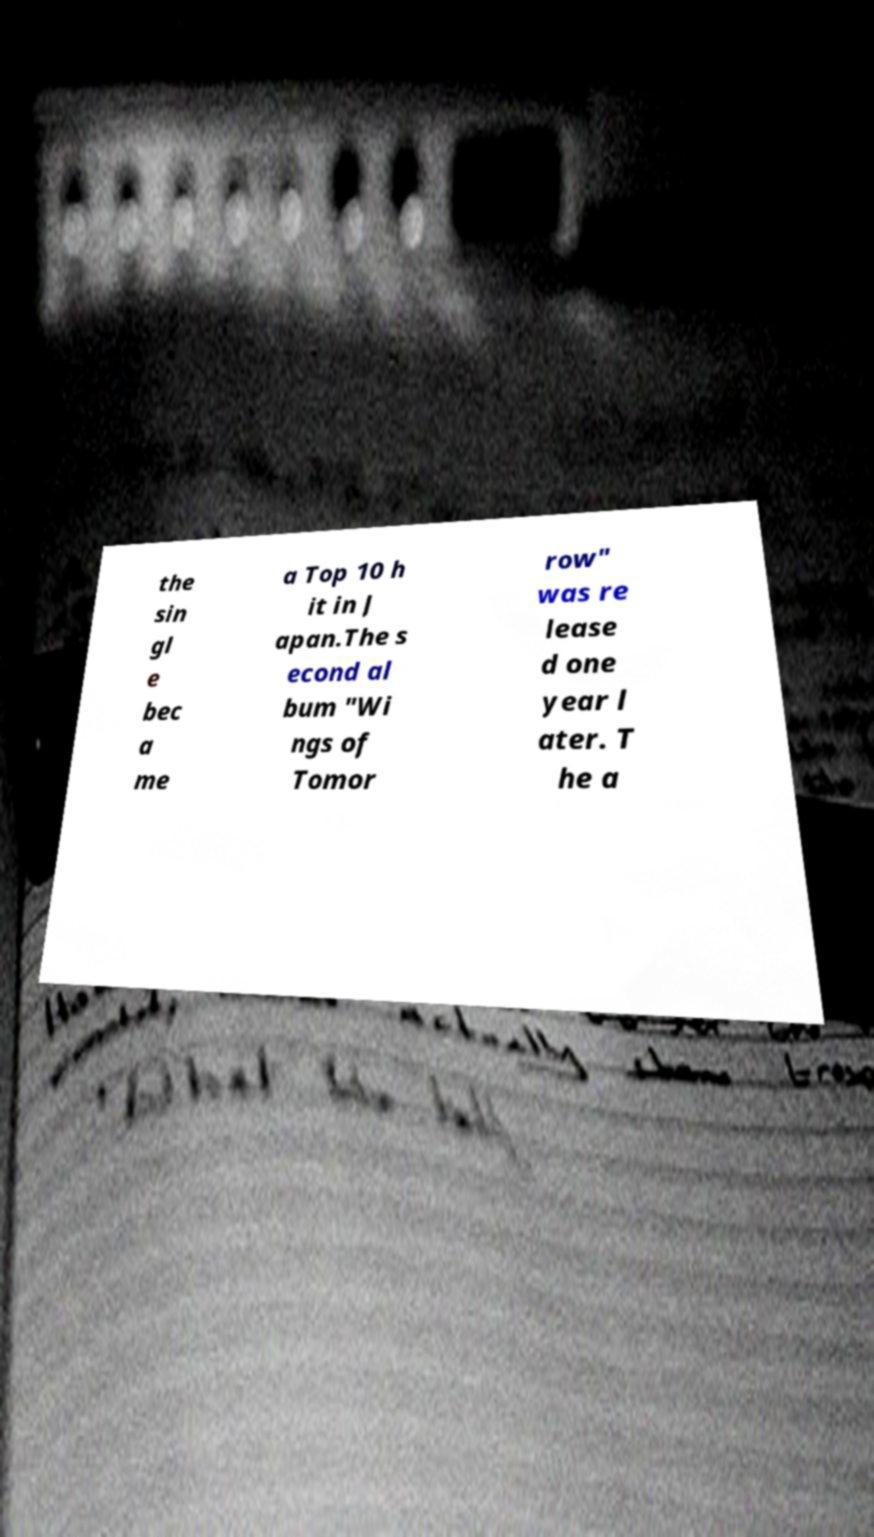For documentation purposes, I need the text within this image transcribed. Could you provide that? the sin gl e bec a me a Top 10 h it in J apan.The s econd al bum "Wi ngs of Tomor row" was re lease d one year l ater. T he a 